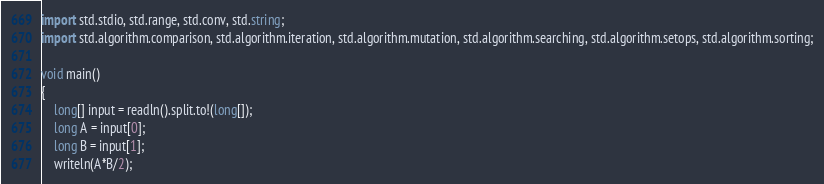<code> <loc_0><loc_0><loc_500><loc_500><_D_>import std.stdio, std.range, std.conv, std.string;
import std.algorithm.comparison, std.algorithm.iteration, std.algorithm.mutation, std.algorithm.searching, std.algorithm.setops, std.algorithm.sorting;

void main()
{
    long[] input = readln().split.to!(long[]);
    long A = input[0];
    long B = input[1];
    writeln(A*B/2);
</code> 